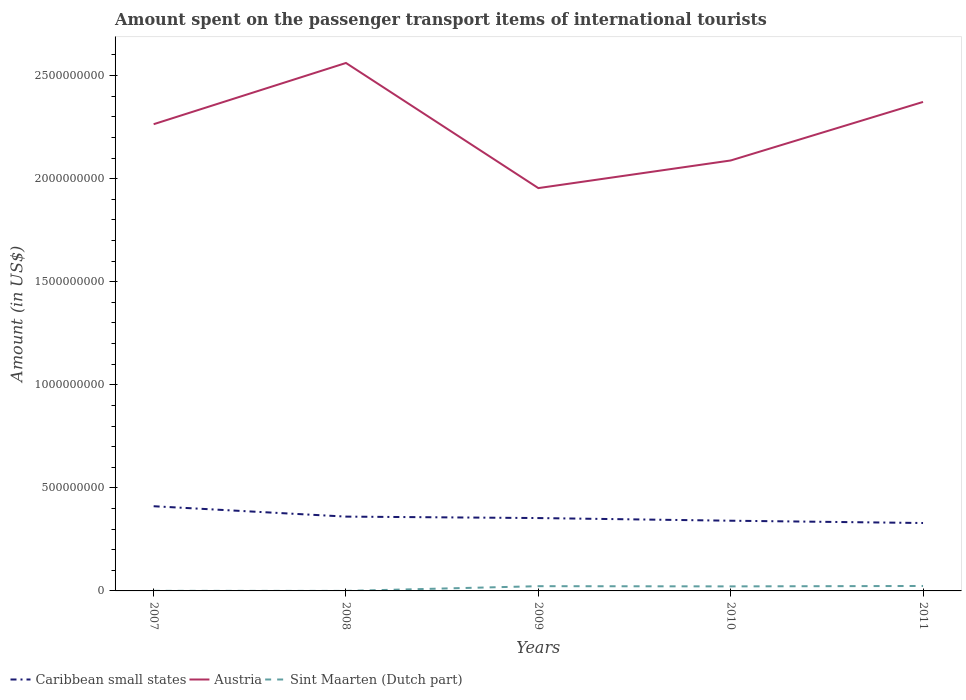How many different coloured lines are there?
Provide a short and direct response. 3. Across all years, what is the maximum amount spent on the passenger transport items of international tourists in Caribbean small states?
Give a very brief answer. 3.29e+08. In which year was the amount spent on the passenger transport items of international tourists in Austria maximum?
Offer a very short reply. 2009. What is the total amount spent on the passenger transport items of international tourists in Austria in the graph?
Offer a terse response. 1.76e+08. What is the difference between the highest and the second highest amount spent on the passenger transport items of international tourists in Caribbean small states?
Your answer should be very brief. 8.14e+07. Is the amount spent on the passenger transport items of international tourists in Sint Maarten (Dutch part) strictly greater than the amount spent on the passenger transport items of international tourists in Caribbean small states over the years?
Ensure brevity in your answer.  Yes. How many lines are there?
Offer a very short reply. 3. What is the difference between two consecutive major ticks on the Y-axis?
Your answer should be compact. 5.00e+08. Are the values on the major ticks of Y-axis written in scientific E-notation?
Give a very brief answer. No. Does the graph contain grids?
Your answer should be compact. No. What is the title of the graph?
Make the answer very short. Amount spent on the passenger transport items of international tourists. Does "Austria" appear as one of the legend labels in the graph?
Your answer should be very brief. Yes. What is the Amount (in US$) of Caribbean small states in 2007?
Make the answer very short. 4.11e+08. What is the Amount (in US$) of Austria in 2007?
Ensure brevity in your answer.  2.26e+09. What is the Amount (in US$) of Sint Maarten (Dutch part) in 2007?
Ensure brevity in your answer.  4.00e+05. What is the Amount (in US$) of Caribbean small states in 2008?
Offer a very short reply. 3.60e+08. What is the Amount (in US$) in Austria in 2008?
Your answer should be compact. 2.56e+09. What is the Amount (in US$) in Caribbean small states in 2009?
Make the answer very short. 3.53e+08. What is the Amount (in US$) in Austria in 2009?
Ensure brevity in your answer.  1.95e+09. What is the Amount (in US$) of Sint Maarten (Dutch part) in 2009?
Give a very brief answer. 2.30e+07. What is the Amount (in US$) of Caribbean small states in 2010?
Offer a terse response. 3.41e+08. What is the Amount (in US$) in Austria in 2010?
Provide a succinct answer. 2.09e+09. What is the Amount (in US$) of Sint Maarten (Dutch part) in 2010?
Give a very brief answer. 2.20e+07. What is the Amount (in US$) of Caribbean small states in 2011?
Your answer should be compact. 3.29e+08. What is the Amount (in US$) in Austria in 2011?
Give a very brief answer. 2.37e+09. What is the Amount (in US$) of Sint Maarten (Dutch part) in 2011?
Provide a succinct answer. 2.40e+07. Across all years, what is the maximum Amount (in US$) in Caribbean small states?
Your response must be concise. 4.11e+08. Across all years, what is the maximum Amount (in US$) of Austria?
Offer a terse response. 2.56e+09. Across all years, what is the maximum Amount (in US$) of Sint Maarten (Dutch part)?
Ensure brevity in your answer.  2.40e+07. Across all years, what is the minimum Amount (in US$) of Caribbean small states?
Provide a short and direct response. 3.29e+08. Across all years, what is the minimum Amount (in US$) in Austria?
Offer a terse response. 1.95e+09. Across all years, what is the minimum Amount (in US$) of Sint Maarten (Dutch part)?
Provide a succinct answer. 1.00e+05. What is the total Amount (in US$) in Caribbean small states in the graph?
Provide a succinct answer. 1.79e+09. What is the total Amount (in US$) in Austria in the graph?
Your answer should be very brief. 1.12e+1. What is the total Amount (in US$) of Sint Maarten (Dutch part) in the graph?
Keep it short and to the point. 6.95e+07. What is the difference between the Amount (in US$) of Caribbean small states in 2007 and that in 2008?
Your answer should be very brief. 5.03e+07. What is the difference between the Amount (in US$) of Austria in 2007 and that in 2008?
Give a very brief answer. -2.97e+08. What is the difference between the Amount (in US$) in Sint Maarten (Dutch part) in 2007 and that in 2008?
Your answer should be compact. 3.00e+05. What is the difference between the Amount (in US$) of Caribbean small states in 2007 and that in 2009?
Give a very brief answer. 5.73e+07. What is the difference between the Amount (in US$) in Austria in 2007 and that in 2009?
Your response must be concise. 3.10e+08. What is the difference between the Amount (in US$) in Sint Maarten (Dutch part) in 2007 and that in 2009?
Give a very brief answer. -2.26e+07. What is the difference between the Amount (in US$) in Caribbean small states in 2007 and that in 2010?
Your answer should be compact. 7.02e+07. What is the difference between the Amount (in US$) in Austria in 2007 and that in 2010?
Your response must be concise. 1.76e+08. What is the difference between the Amount (in US$) of Sint Maarten (Dutch part) in 2007 and that in 2010?
Your response must be concise. -2.16e+07. What is the difference between the Amount (in US$) of Caribbean small states in 2007 and that in 2011?
Make the answer very short. 8.14e+07. What is the difference between the Amount (in US$) in Austria in 2007 and that in 2011?
Offer a very short reply. -1.08e+08. What is the difference between the Amount (in US$) of Sint Maarten (Dutch part) in 2007 and that in 2011?
Provide a short and direct response. -2.36e+07. What is the difference between the Amount (in US$) of Caribbean small states in 2008 and that in 2009?
Make the answer very short. 7.02e+06. What is the difference between the Amount (in US$) of Austria in 2008 and that in 2009?
Provide a short and direct response. 6.07e+08. What is the difference between the Amount (in US$) of Sint Maarten (Dutch part) in 2008 and that in 2009?
Offer a terse response. -2.29e+07. What is the difference between the Amount (in US$) of Caribbean small states in 2008 and that in 2010?
Offer a very short reply. 1.99e+07. What is the difference between the Amount (in US$) in Austria in 2008 and that in 2010?
Make the answer very short. 4.73e+08. What is the difference between the Amount (in US$) of Sint Maarten (Dutch part) in 2008 and that in 2010?
Offer a terse response. -2.19e+07. What is the difference between the Amount (in US$) of Caribbean small states in 2008 and that in 2011?
Provide a succinct answer. 3.10e+07. What is the difference between the Amount (in US$) of Austria in 2008 and that in 2011?
Keep it short and to the point. 1.89e+08. What is the difference between the Amount (in US$) of Sint Maarten (Dutch part) in 2008 and that in 2011?
Keep it short and to the point. -2.39e+07. What is the difference between the Amount (in US$) of Caribbean small states in 2009 and that in 2010?
Your answer should be compact. 1.29e+07. What is the difference between the Amount (in US$) in Austria in 2009 and that in 2010?
Provide a short and direct response. -1.34e+08. What is the difference between the Amount (in US$) of Caribbean small states in 2009 and that in 2011?
Ensure brevity in your answer.  2.40e+07. What is the difference between the Amount (in US$) of Austria in 2009 and that in 2011?
Make the answer very short. -4.18e+08. What is the difference between the Amount (in US$) of Caribbean small states in 2010 and that in 2011?
Your answer should be compact. 1.11e+07. What is the difference between the Amount (in US$) in Austria in 2010 and that in 2011?
Offer a terse response. -2.84e+08. What is the difference between the Amount (in US$) of Caribbean small states in 2007 and the Amount (in US$) of Austria in 2008?
Offer a terse response. -2.15e+09. What is the difference between the Amount (in US$) of Caribbean small states in 2007 and the Amount (in US$) of Sint Maarten (Dutch part) in 2008?
Give a very brief answer. 4.11e+08. What is the difference between the Amount (in US$) of Austria in 2007 and the Amount (in US$) of Sint Maarten (Dutch part) in 2008?
Offer a terse response. 2.26e+09. What is the difference between the Amount (in US$) in Caribbean small states in 2007 and the Amount (in US$) in Austria in 2009?
Your answer should be compact. -1.54e+09. What is the difference between the Amount (in US$) in Caribbean small states in 2007 and the Amount (in US$) in Sint Maarten (Dutch part) in 2009?
Ensure brevity in your answer.  3.88e+08. What is the difference between the Amount (in US$) in Austria in 2007 and the Amount (in US$) in Sint Maarten (Dutch part) in 2009?
Keep it short and to the point. 2.24e+09. What is the difference between the Amount (in US$) of Caribbean small states in 2007 and the Amount (in US$) of Austria in 2010?
Provide a short and direct response. -1.68e+09. What is the difference between the Amount (in US$) of Caribbean small states in 2007 and the Amount (in US$) of Sint Maarten (Dutch part) in 2010?
Your answer should be compact. 3.89e+08. What is the difference between the Amount (in US$) of Austria in 2007 and the Amount (in US$) of Sint Maarten (Dutch part) in 2010?
Give a very brief answer. 2.24e+09. What is the difference between the Amount (in US$) in Caribbean small states in 2007 and the Amount (in US$) in Austria in 2011?
Ensure brevity in your answer.  -1.96e+09. What is the difference between the Amount (in US$) in Caribbean small states in 2007 and the Amount (in US$) in Sint Maarten (Dutch part) in 2011?
Provide a short and direct response. 3.87e+08. What is the difference between the Amount (in US$) in Austria in 2007 and the Amount (in US$) in Sint Maarten (Dutch part) in 2011?
Your answer should be very brief. 2.24e+09. What is the difference between the Amount (in US$) in Caribbean small states in 2008 and the Amount (in US$) in Austria in 2009?
Ensure brevity in your answer.  -1.59e+09. What is the difference between the Amount (in US$) in Caribbean small states in 2008 and the Amount (in US$) in Sint Maarten (Dutch part) in 2009?
Provide a short and direct response. 3.37e+08. What is the difference between the Amount (in US$) in Austria in 2008 and the Amount (in US$) in Sint Maarten (Dutch part) in 2009?
Offer a terse response. 2.54e+09. What is the difference between the Amount (in US$) in Caribbean small states in 2008 and the Amount (in US$) in Austria in 2010?
Provide a succinct answer. -1.73e+09. What is the difference between the Amount (in US$) of Caribbean small states in 2008 and the Amount (in US$) of Sint Maarten (Dutch part) in 2010?
Your response must be concise. 3.38e+08. What is the difference between the Amount (in US$) of Austria in 2008 and the Amount (in US$) of Sint Maarten (Dutch part) in 2010?
Provide a short and direct response. 2.54e+09. What is the difference between the Amount (in US$) of Caribbean small states in 2008 and the Amount (in US$) of Austria in 2011?
Make the answer very short. -2.01e+09. What is the difference between the Amount (in US$) in Caribbean small states in 2008 and the Amount (in US$) in Sint Maarten (Dutch part) in 2011?
Provide a short and direct response. 3.36e+08. What is the difference between the Amount (in US$) of Austria in 2008 and the Amount (in US$) of Sint Maarten (Dutch part) in 2011?
Ensure brevity in your answer.  2.54e+09. What is the difference between the Amount (in US$) in Caribbean small states in 2009 and the Amount (in US$) in Austria in 2010?
Provide a succinct answer. -1.73e+09. What is the difference between the Amount (in US$) of Caribbean small states in 2009 and the Amount (in US$) of Sint Maarten (Dutch part) in 2010?
Offer a terse response. 3.31e+08. What is the difference between the Amount (in US$) in Austria in 2009 and the Amount (in US$) in Sint Maarten (Dutch part) in 2010?
Make the answer very short. 1.93e+09. What is the difference between the Amount (in US$) of Caribbean small states in 2009 and the Amount (in US$) of Austria in 2011?
Provide a succinct answer. -2.02e+09. What is the difference between the Amount (in US$) of Caribbean small states in 2009 and the Amount (in US$) of Sint Maarten (Dutch part) in 2011?
Provide a short and direct response. 3.29e+08. What is the difference between the Amount (in US$) of Austria in 2009 and the Amount (in US$) of Sint Maarten (Dutch part) in 2011?
Your answer should be very brief. 1.93e+09. What is the difference between the Amount (in US$) in Caribbean small states in 2010 and the Amount (in US$) in Austria in 2011?
Provide a succinct answer. -2.03e+09. What is the difference between the Amount (in US$) of Caribbean small states in 2010 and the Amount (in US$) of Sint Maarten (Dutch part) in 2011?
Your response must be concise. 3.17e+08. What is the difference between the Amount (in US$) of Austria in 2010 and the Amount (in US$) of Sint Maarten (Dutch part) in 2011?
Give a very brief answer. 2.06e+09. What is the average Amount (in US$) in Caribbean small states per year?
Provide a succinct answer. 3.59e+08. What is the average Amount (in US$) in Austria per year?
Provide a short and direct response. 2.25e+09. What is the average Amount (in US$) in Sint Maarten (Dutch part) per year?
Your response must be concise. 1.39e+07. In the year 2007, what is the difference between the Amount (in US$) of Caribbean small states and Amount (in US$) of Austria?
Keep it short and to the point. -1.85e+09. In the year 2007, what is the difference between the Amount (in US$) in Caribbean small states and Amount (in US$) in Sint Maarten (Dutch part)?
Your answer should be very brief. 4.10e+08. In the year 2007, what is the difference between the Amount (in US$) of Austria and Amount (in US$) of Sint Maarten (Dutch part)?
Keep it short and to the point. 2.26e+09. In the year 2008, what is the difference between the Amount (in US$) of Caribbean small states and Amount (in US$) of Austria?
Give a very brief answer. -2.20e+09. In the year 2008, what is the difference between the Amount (in US$) in Caribbean small states and Amount (in US$) in Sint Maarten (Dutch part)?
Provide a short and direct response. 3.60e+08. In the year 2008, what is the difference between the Amount (in US$) in Austria and Amount (in US$) in Sint Maarten (Dutch part)?
Provide a short and direct response. 2.56e+09. In the year 2009, what is the difference between the Amount (in US$) of Caribbean small states and Amount (in US$) of Austria?
Your response must be concise. -1.60e+09. In the year 2009, what is the difference between the Amount (in US$) in Caribbean small states and Amount (in US$) in Sint Maarten (Dutch part)?
Give a very brief answer. 3.30e+08. In the year 2009, what is the difference between the Amount (in US$) of Austria and Amount (in US$) of Sint Maarten (Dutch part)?
Ensure brevity in your answer.  1.93e+09. In the year 2010, what is the difference between the Amount (in US$) of Caribbean small states and Amount (in US$) of Austria?
Keep it short and to the point. -1.75e+09. In the year 2010, what is the difference between the Amount (in US$) in Caribbean small states and Amount (in US$) in Sint Maarten (Dutch part)?
Keep it short and to the point. 3.19e+08. In the year 2010, what is the difference between the Amount (in US$) in Austria and Amount (in US$) in Sint Maarten (Dutch part)?
Offer a very short reply. 2.07e+09. In the year 2011, what is the difference between the Amount (in US$) of Caribbean small states and Amount (in US$) of Austria?
Offer a very short reply. -2.04e+09. In the year 2011, what is the difference between the Amount (in US$) in Caribbean small states and Amount (in US$) in Sint Maarten (Dutch part)?
Give a very brief answer. 3.05e+08. In the year 2011, what is the difference between the Amount (in US$) in Austria and Amount (in US$) in Sint Maarten (Dutch part)?
Make the answer very short. 2.35e+09. What is the ratio of the Amount (in US$) in Caribbean small states in 2007 to that in 2008?
Your response must be concise. 1.14. What is the ratio of the Amount (in US$) of Austria in 2007 to that in 2008?
Your answer should be compact. 0.88. What is the ratio of the Amount (in US$) in Caribbean small states in 2007 to that in 2009?
Provide a succinct answer. 1.16. What is the ratio of the Amount (in US$) in Austria in 2007 to that in 2009?
Provide a succinct answer. 1.16. What is the ratio of the Amount (in US$) in Sint Maarten (Dutch part) in 2007 to that in 2009?
Give a very brief answer. 0.02. What is the ratio of the Amount (in US$) in Caribbean small states in 2007 to that in 2010?
Provide a short and direct response. 1.21. What is the ratio of the Amount (in US$) of Austria in 2007 to that in 2010?
Provide a short and direct response. 1.08. What is the ratio of the Amount (in US$) in Sint Maarten (Dutch part) in 2007 to that in 2010?
Ensure brevity in your answer.  0.02. What is the ratio of the Amount (in US$) in Caribbean small states in 2007 to that in 2011?
Provide a short and direct response. 1.25. What is the ratio of the Amount (in US$) of Austria in 2007 to that in 2011?
Your response must be concise. 0.95. What is the ratio of the Amount (in US$) of Sint Maarten (Dutch part) in 2007 to that in 2011?
Offer a very short reply. 0.02. What is the ratio of the Amount (in US$) of Caribbean small states in 2008 to that in 2009?
Offer a very short reply. 1.02. What is the ratio of the Amount (in US$) of Austria in 2008 to that in 2009?
Make the answer very short. 1.31. What is the ratio of the Amount (in US$) in Sint Maarten (Dutch part) in 2008 to that in 2009?
Your answer should be compact. 0. What is the ratio of the Amount (in US$) in Caribbean small states in 2008 to that in 2010?
Offer a very short reply. 1.06. What is the ratio of the Amount (in US$) of Austria in 2008 to that in 2010?
Give a very brief answer. 1.23. What is the ratio of the Amount (in US$) of Sint Maarten (Dutch part) in 2008 to that in 2010?
Give a very brief answer. 0. What is the ratio of the Amount (in US$) of Caribbean small states in 2008 to that in 2011?
Your answer should be compact. 1.09. What is the ratio of the Amount (in US$) in Austria in 2008 to that in 2011?
Your answer should be compact. 1.08. What is the ratio of the Amount (in US$) of Sint Maarten (Dutch part) in 2008 to that in 2011?
Keep it short and to the point. 0. What is the ratio of the Amount (in US$) of Caribbean small states in 2009 to that in 2010?
Your response must be concise. 1.04. What is the ratio of the Amount (in US$) of Austria in 2009 to that in 2010?
Offer a very short reply. 0.94. What is the ratio of the Amount (in US$) in Sint Maarten (Dutch part) in 2009 to that in 2010?
Keep it short and to the point. 1.05. What is the ratio of the Amount (in US$) in Caribbean small states in 2009 to that in 2011?
Provide a succinct answer. 1.07. What is the ratio of the Amount (in US$) in Austria in 2009 to that in 2011?
Your answer should be compact. 0.82. What is the ratio of the Amount (in US$) in Sint Maarten (Dutch part) in 2009 to that in 2011?
Your response must be concise. 0.96. What is the ratio of the Amount (in US$) in Caribbean small states in 2010 to that in 2011?
Your answer should be compact. 1.03. What is the ratio of the Amount (in US$) of Austria in 2010 to that in 2011?
Keep it short and to the point. 0.88. What is the difference between the highest and the second highest Amount (in US$) of Caribbean small states?
Your response must be concise. 5.03e+07. What is the difference between the highest and the second highest Amount (in US$) in Austria?
Give a very brief answer. 1.89e+08. What is the difference between the highest and the second highest Amount (in US$) in Sint Maarten (Dutch part)?
Ensure brevity in your answer.  1.00e+06. What is the difference between the highest and the lowest Amount (in US$) in Caribbean small states?
Keep it short and to the point. 8.14e+07. What is the difference between the highest and the lowest Amount (in US$) of Austria?
Keep it short and to the point. 6.07e+08. What is the difference between the highest and the lowest Amount (in US$) of Sint Maarten (Dutch part)?
Give a very brief answer. 2.39e+07. 